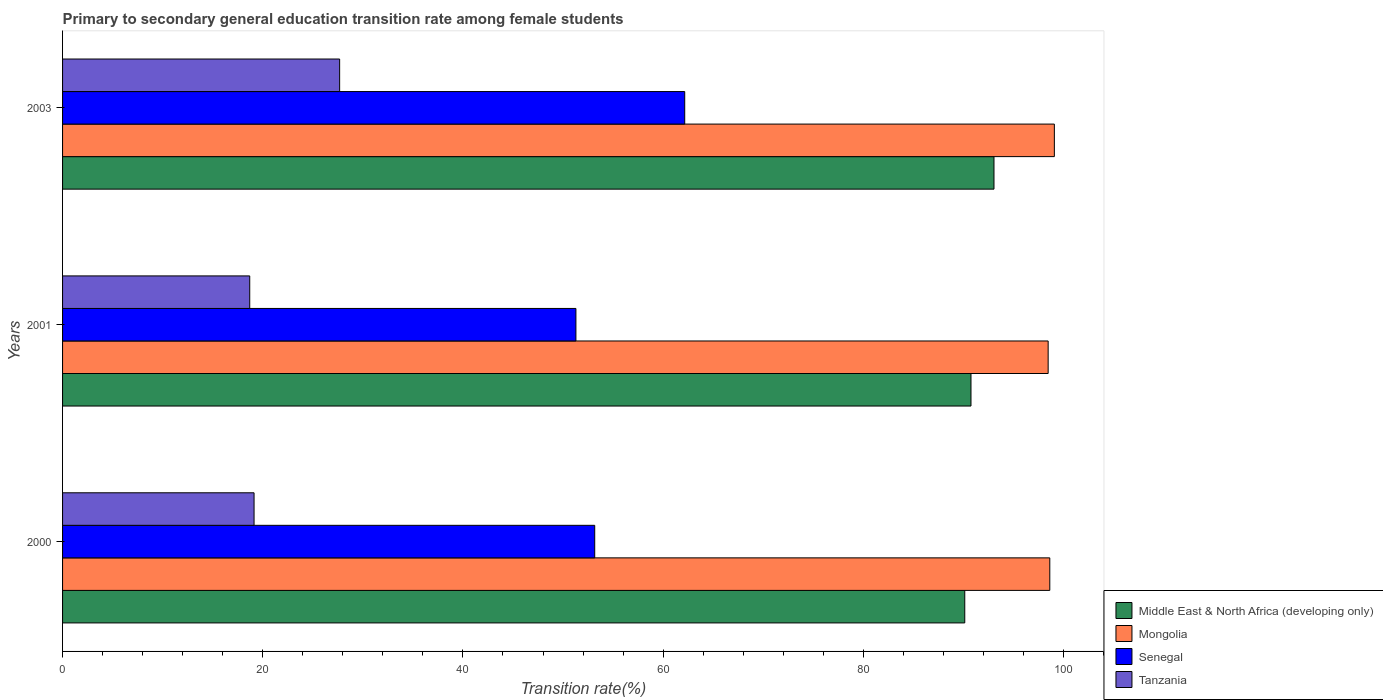How many different coloured bars are there?
Keep it short and to the point. 4. How many bars are there on the 2nd tick from the bottom?
Ensure brevity in your answer.  4. In how many cases, is the number of bars for a given year not equal to the number of legend labels?
Offer a very short reply. 0. What is the transition rate in Senegal in 2003?
Offer a very short reply. 62.16. Across all years, what is the maximum transition rate in Tanzania?
Offer a very short reply. 27.68. Across all years, what is the minimum transition rate in Middle East & North Africa (developing only)?
Your answer should be very brief. 90.14. In which year was the transition rate in Senegal maximum?
Give a very brief answer. 2003. In which year was the transition rate in Middle East & North Africa (developing only) minimum?
Make the answer very short. 2000. What is the total transition rate in Middle East & North Africa (developing only) in the graph?
Offer a very short reply. 273.96. What is the difference between the transition rate in Mongolia in 2001 and that in 2003?
Your answer should be very brief. -0.62. What is the difference between the transition rate in Tanzania in 2000 and the transition rate in Mongolia in 2003?
Your response must be concise. -79.96. What is the average transition rate in Middle East & North Africa (developing only) per year?
Provide a short and direct response. 91.32. In the year 2000, what is the difference between the transition rate in Senegal and transition rate in Middle East & North Africa (developing only)?
Offer a terse response. -36.97. In how many years, is the transition rate in Tanzania greater than 56 %?
Give a very brief answer. 0. What is the ratio of the transition rate in Middle East & North Africa (developing only) in 2000 to that in 2003?
Your response must be concise. 0.97. Is the transition rate in Middle East & North Africa (developing only) in 2000 less than that in 2001?
Your answer should be very brief. Yes. Is the difference between the transition rate in Senegal in 2001 and 2003 greater than the difference between the transition rate in Middle East & North Africa (developing only) in 2001 and 2003?
Ensure brevity in your answer.  No. What is the difference between the highest and the second highest transition rate in Senegal?
Provide a short and direct response. 8.99. What is the difference between the highest and the lowest transition rate in Senegal?
Make the answer very short. 10.87. In how many years, is the transition rate in Tanzania greater than the average transition rate in Tanzania taken over all years?
Offer a terse response. 1. Is it the case that in every year, the sum of the transition rate in Middle East & North Africa (developing only) and transition rate in Mongolia is greater than the sum of transition rate in Tanzania and transition rate in Senegal?
Your answer should be compact. Yes. What does the 3rd bar from the top in 2003 represents?
Your response must be concise. Mongolia. What does the 1st bar from the bottom in 2001 represents?
Provide a succinct answer. Middle East & North Africa (developing only). Is it the case that in every year, the sum of the transition rate in Senegal and transition rate in Tanzania is greater than the transition rate in Middle East & North Africa (developing only)?
Offer a terse response. No. How many bars are there?
Offer a terse response. 12. How many years are there in the graph?
Provide a short and direct response. 3. Does the graph contain any zero values?
Make the answer very short. No. How many legend labels are there?
Offer a very short reply. 4. How are the legend labels stacked?
Provide a short and direct response. Vertical. What is the title of the graph?
Give a very brief answer. Primary to secondary general education transition rate among female students. Does "Morocco" appear as one of the legend labels in the graph?
Provide a short and direct response. No. What is the label or title of the X-axis?
Offer a terse response. Transition rate(%). What is the label or title of the Y-axis?
Your response must be concise. Years. What is the Transition rate(%) of Middle East & North Africa (developing only) in 2000?
Your answer should be compact. 90.14. What is the Transition rate(%) in Mongolia in 2000?
Your response must be concise. 98.64. What is the Transition rate(%) in Senegal in 2000?
Offer a terse response. 53.17. What is the Transition rate(%) in Tanzania in 2000?
Your response must be concise. 19.13. What is the Transition rate(%) of Middle East & North Africa (developing only) in 2001?
Provide a short and direct response. 90.76. What is the Transition rate(%) in Mongolia in 2001?
Provide a succinct answer. 98.47. What is the Transition rate(%) of Senegal in 2001?
Offer a very short reply. 51.29. What is the Transition rate(%) of Tanzania in 2001?
Offer a very short reply. 18.7. What is the Transition rate(%) of Middle East & North Africa (developing only) in 2003?
Offer a very short reply. 93.06. What is the Transition rate(%) in Mongolia in 2003?
Keep it short and to the point. 99.09. What is the Transition rate(%) in Senegal in 2003?
Provide a succinct answer. 62.16. What is the Transition rate(%) of Tanzania in 2003?
Provide a short and direct response. 27.68. Across all years, what is the maximum Transition rate(%) in Middle East & North Africa (developing only)?
Give a very brief answer. 93.06. Across all years, what is the maximum Transition rate(%) of Mongolia?
Provide a short and direct response. 99.09. Across all years, what is the maximum Transition rate(%) in Senegal?
Your answer should be very brief. 62.16. Across all years, what is the maximum Transition rate(%) of Tanzania?
Ensure brevity in your answer.  27.68. Across all years, what is the minimum Transition rate(%) of Middle East & North Africa (developing only)?
Offer a very short reply. 90.14. Across all years, what is the minimum Transition rate(%) in Mongolia?
Give a very brief answer. 98.47. Across all years, what is the minimum Transition rate(%) of Senegal?
Provide a succinct answer. 51.29. Across all years, what is the minimum Transition rate(%) of Tanzania?
Keep it short and to the point. 18.7. What is the total Transition rate(%) in Middle East & North Africa (developing only) in the graph?
Provide a succinct answer. 273.96. What is the total Transition rate(%) of Mongolia in the graph?
Offer a terse response. 296.2. What is the total Transition rate(%) in Senegal in the graph?
Offer a very short reply. 166.62. What is the total Transition rate(%) of Tanzania in the graph?
Provide a succinct answer. 65.52. What is the difference between the Transition rate(%) of Middle East & North Africa (developing only) in 2000 and that in 2001?
Ensure brevity in your answer.  -0.62. What is the difference between the Transition rate(%) of Mongolia in 2000 and that in 2001?
Make the answer very short. 0.16. What is the difference between the Transition rate(%) in Senegal in 2000 and that in 2001?
Your answer should be very brief. 1.88. What is the difference between the Transition rate(%) of Tanzania in 2000 and that in 2001?
Offer a very short reply. 0.43. What is the difference between the Transition rate(%) of Middle East & North Africa (developing only) in 2000 and that in 2003?
Offer a very short reply. -2.92. What is the difference between the Transition rate(%) in Mongolia in 2000 and that in 2003?
Your answer should be compact. -0.46. What is the difference between the Transition rate(%) of Senegal in 2000 and that in 2003?
Your answer should be very brief. -8.99. What is the difference between the Transition rate(%) of Tanzania in 2000 and that in 2003?
Provide a succinct answer. -8.55. What is the difference between the Transition rate(%) in Middle East & North Africa (developing only) in 2001 and that in 2003?
Offer a terse response. -2.3. What is the difference between the Transition rate(%) of Mongolia in 2001 and that in 2003?
Offer a very short reply. -0.62. What is the difference between the Transition rate(%) of Senegal in 2001 and that in 2003?
Provide a short and direct response. -10.87. What is the difference between the Transition rate(%) in Tanzania in 2001 and that in 2003?
Your answer should be very brief. -8.98. What is the difference between the Transition rate(%) of Middle East & North Africa (developing only) in 2000 and the Transition rate(%) of Mongolia in 2001?
Offer a terse response. -8.33. What is the difference between the Transition rate(%) in Middle East & North Africa (developing only) in 2000 and the Transition rate(%) in Senegal in 2001?
Offer a very short reply. 38.85. What is the difference between the Transition rate(%) in Middle East & North Africa (developing only) in 2000 and the Transition rate(%) in Tanzania in 2001?
Offer a terse response. 71.44. What is the difference between the Transition rate(%) in Mongolia in 2000 and the Transition rate(%) in Senegal in 2001?
Your response must be concise. 47.35. What is the difference between the Transition rate(%) in Mongolia in 2000 and the Transition rate(%) in Tanzania in 2001?
Offer a very short reply. 79.94. What is the difference between the Transition rate(%) of Senegal in 2000 and the Transition rate(%) of Tanzania in 2001?
Offer a terse response. 34.47. What is the difference between the Transition rate(%) of Middle East & North Africa (developing only) in 2000 and the Transition rate(%) of Mongolia in 2003?
Offer a very short reply. -8.95. What is the difference between the Transition rate(%) of Middle East & North Africa (developing only) in 2000 and the Transition rate(%) of Senegal in 2003?
Ensure brevity in your answer.  27.98. What is the difference between the Transition rate(%) of Middle East & North Africa (developing only) in 2000 and the Transition rate(%) of Tanzania in 2003?
Keep it short and to the point. 62.46. What is the difference between the Transition rate(%) in Mongolia in 2000 and the Transition rate(%) in Senegal in 2003?
Offer a terse response. 36.47. What is the difference between the Transition rate(%) of Mongolia in 2000 and the Transition rate(%) of Tanzania in 2003?
Your response must be concise. 70.95. What is the difference between the Transition rate(%) in Senegal in 2000 and the Transition rate(%) in Tanzania in 2003?
Make the answer very short. 25.48. What is the difference between the Transition rate(%) in Middle East & North Africa (developing only) in 2001 and the Transition rate(%) in Mongolia in 2003?
Your response must be concise. -8.33. What is the difference between the Transition rate(%) in Middle East & North Africa (developing only) in 2001 and the Transition rate(%) in Senegal in 2003?
Provide a succinct answer. 28.6. What is the difference between the Transition rate(%) of Middle East & North Africa (developing only) in 2001 and the Transition rate(%) of Tanzania in 2003?
Give a very brief answer. 63.08. What is the difference between the Transition rate(%) of Mongolia in 2001 and the Transition rate(%) of Senegal in 2003?
Your response must be concise. 36.31. What is the difference between the Transition rate(%) in Mongolia in 2001 and the Transition rate(%) in Tanzania in 2003?
Offer a terse response. 70.79. What is the difference between the Transition rate(%) in Senegal in 2001 and the Transition rate(%) in Tanzania in 2003?
Your response must be concise. 23.61. What is the average Transition rate(%) of Middle East & North Africa (developing only) per year?
Ensure brevity in your answer.  91.32. What is the average Transition rate(%) of Mongolia per year?
Give a very brief answer. 98.73. What is the average Transition rate(%) in Senegal per year?
Provide a short and direct response. 55.54. What is the average Transition rate(%) of Tanzania per year?
Make the answer very short. 21.84. In the year 2000, what is the difference between the Transition rate(%) of Middle East & North Africa (developing only) and Transition rate(%) of Mongolia?
Provide a succinct answer. -8.5. In the year 2000, what is the difference between the Transition rate(%) of Middle East & North Africa (developing only) and Transition rate(%) of Senegal?
Offer a very short reply. 36.97. In the year 2000, what is the difference between the Transition rate(%) of Middle East & North Africa (developing only) and Transition rate(%) of Tanzania?
Provide a short and direct response. 71.01. In the year 2000, what is the difference between the Transition rate(%) of Mongolia and Transition rate(%) of Senegal?
Give a very brief answer. 45.47. In the year 2000, what is the difference between the Transition rate(%) in Mongolia and Transition rate(%) in Tanzania?
Make the answer very short. 79.5. In the year 2000, what is the difference between the Transition rate(%) in Senegal and Transition rate(%) in Tanzania?
Provide a short and direct response. 34.03. In the year 2001, what is the difference between the Transition rate(%) of Middle East & North Africa (developing only) and Transition rate(%) of Mongolia?
Provide a succinct answer. -7.71. In the year 2001, what is the difference between the Transition rate(%) of Middle East & North Africa (developing only) and Transition rate(%) of Senegal?
Offer a very short reply. 39.47. In the year 2001, what is the difference between the Transition rate(%) of Middle East & North Africa (developing only) and Transition rate(%) of Tanzania?
Make the answer very short. 72.06. In the year 2001, what is the difference between the Transition rate(%) in Mongolia and Transition rate(%) in Senegal?
Give a very brief answer. 47.18. In the year 2001, what is the difference between the Transition rate(%) of Mongolia and Transition rate(%) of Tanzania?
Provide a succinct answer. 79.77. In the year 2001, what is the difference between the Transition rate(%) of Senegal and Transition rate(%) of Tanzania?
Your answer should be very brief. 32.59. In the year 2003, what is the difference between the Transition rate(%) of Middle East & North Africa (developing only) and Transition rate(%) of Mongolia?
Provide a short and direct response. -6.03. In the year 2003, what is the difference between the Transition rate(%) in Middle East & North Africa (developing only) and Transition rate(%) in Senegal?
Offer a terse response. 30.9. In the year 2003, what is the difference between the Transition rate(%) of Middle East & North Africa (developing only) and Transition rate(%) of Tanzania?
Ensure brevity in your answer.  65.38. In the year 2003, what is the difference between the Transition rate(%) in Mongolia and Transition rate(%) in Senegal?
Your answer should be compact. 36.93. In the year 2003, what is the difference between the Transition rate(%) of Mongolia and Transition rate(%) of Tanzania?
Your answer should be very brief. 71.41. In the year 2003, what is the difference between the Transition rate(%) of Senegal and Transition rate(%) of Tanzania?
Make the answer very short. 34.48. What is the ratio of the Transition rate(%) in Senegal in 2000 to that in 2001?
Offer a terse response. 1.04. What is the ratio of the Transition rate(%) of Tanzania in 2000 to that in 2001?
Provide a short and direct response. 1.02. What is the ratio of the Transition rate(%) of Middle East & North Africa (developing only) in 2000 to that in 2003?
Keep it short and to the point. 0.97. What is the ratio of the Transition rate(%) of Mongolia in 2000 to that in 2003?
Make the answer very short. 1. What is the ratio of the Transition rate(%) of Senegal in 2000 to that in 2003?
Give a very brief answer. 0.86. What is the ratio of the Transition rate(%) in Tanzania in 2000 to that in 2003?
Provide a succinct answer. 0.69. What is the ratio of the Transition rate(%) in Middle East & North Africa (developing only) in 2001 to that in 2003?
Provide a short and direct response. 0.98. What is the ratio of the Transition rate(%) in Senegal in 2001 to that in 2003?
Offer a terse response. 0.83. What is the ratio of the Transition rate(%) of Tanzania in 2001 to that in 2003?
Provide a short and direct response. 0.68. What is the difference between the highest and the second highest Transition rate(%) in Middle East & North Africa (developing only)?
Offer a very short reply. 2.3. What is the difference between the highest and the second highest Transition rate(%) in Mongolia?
Ensure brevity in your answer.  0.46. What is the difference between the highest and the second highest Transition rate(%) of Senegal?
Your answer should be very brief. 8.99. What is the difference between the highest and the second highest Transition rate(%) in Tanzania?
Ensure brevity in your answer.  8.55. What is the difference between the highest and the lowest Transition rate(%) in Middle East & North Africa (developing only)?
Make the answer very short. 2.92. What is the difference between the highest and the lowest Transition rate(%) of Mongolia?
Your answer should be very brief. 0.62. What is the difference between the highest and the lowest Transition rate(%) of Senegal?
Your answer should be compact. 10.87. What is the difference between the highest and the lowest Transition rate(%) in Tanzania?
Your response must be concise. 8.98. 